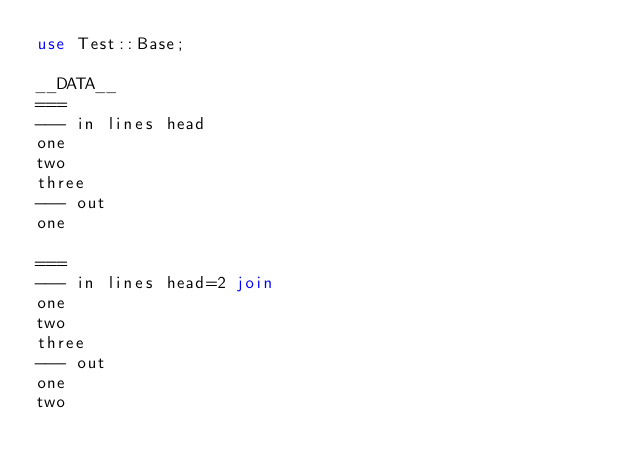<code> <loc_0><loc_0><loc_500><loc_500><_Perl_>use Test::Base;

__DATA__
===
--- in lines head
one
two
three
--- out
one

===
--- in lines head=2 join
one
two
three
--- out
one
two
</code> 